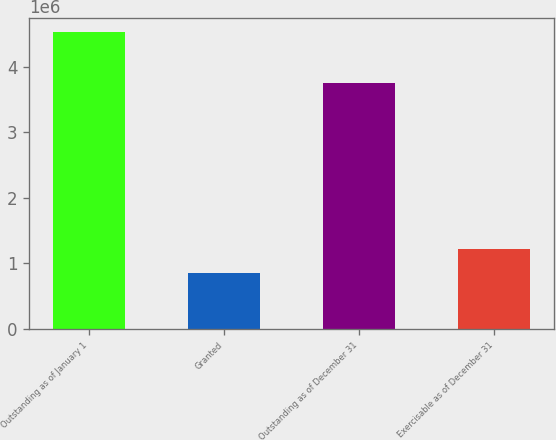Convert chart. <chart><loc_0><loc_0><loc_500><loc_500><bar_chart><fcel>Outstanding as of January 1<fcel>Granted<fcel>Outstanding as of December 31<fcel>Exercisable as of December 31<nl><fcel>4.53098e+06<fcel>845440<fcel>3.75795e+06<fcel>1.21399e+06<nl></chart> 